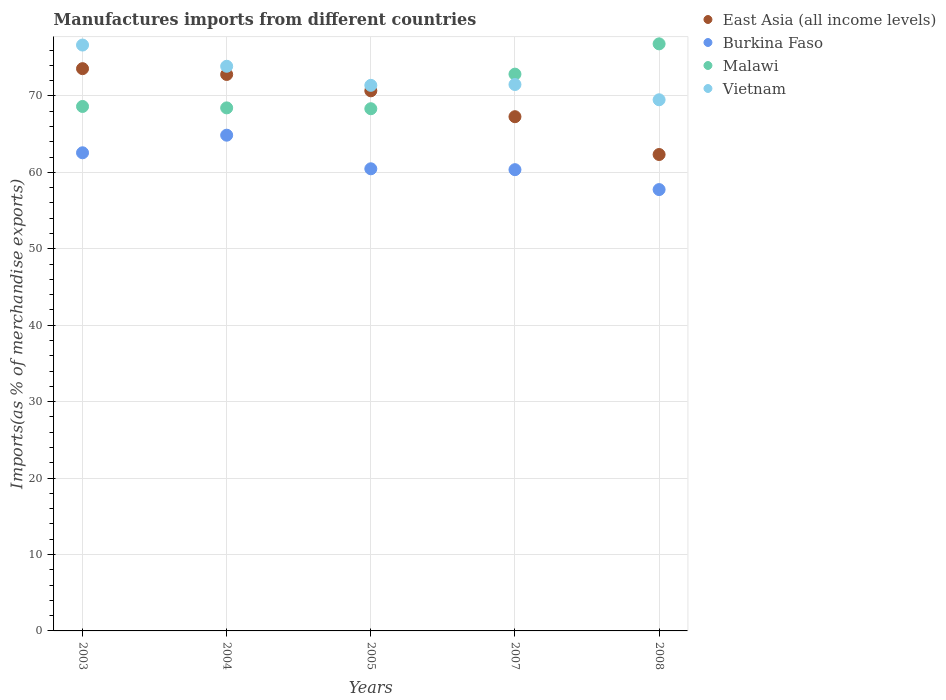How many different coloured dotlines are there?
Provide a succinct answer. 4. Is the number of dotlines equal to the number of legend labels?
Ensure brevity in your answer.  Yes. What is the percentage of imports to different countries in Malawi in 2007?
Ensure brevity in your answer.  72.86. Across all years, what is the maximum percentage of imports to different countries in Vietnam?
Your answer should be compact. 76.67. Across all years, what is the minimum percentage of imports to different countries in Vietnam?
Provide a short and direct response. 69.51. In which year was the percentage of imports to different countries in Malawi maximum?
Keep it short and to the point. 2008. In which year was the percentage of imports to different countries in East Asia (all income levels) minimum?
Your answer should be compact. 2008. What is the total percentage of imports to different countries in Vietnam in the graph?
Ensure brevity in your answer.  362.96. What is the difference between the percentage of imports to different countries in Vietnam in 2003 and that in 2005?
Offer a terse response. 5.27. What is the difference between the percentage of imports to different countries in East Asia (all income levels) in 2004 and the percentage of imports to different countries in Malawi in 2003?
Keep it short and to the point. 4.19. What is the average percentage of imports to different countries in Burkina Faso per year?
Your answer should be compact. 61.21. In the year 2007, what is the difference between the percentage of imports to different countries in Vietnam and percentage of imports to different countries in East Asia (all income levels)?
Your response must be concise. 4.21. In how many years, is the percentage of imports to different countries in Burkina Faso greater than 8 %?
Offer a terse response. 5. What is the ratio of the percentage of imports to different countries in Vietnam in 2005 to that in 2008?
Ensure brevity in your answer.  1.03. What is the difference between the highest and the second highest percentage of imports to different countries in Burkina Faso?
Provide a short and direct response. 2.3. What is the difference between the highest and the lowest percentage of imports to different countries in East Asia (all income levels)?
Give a very brief answer. 11.23. Is it the case that in every year, the sum of the percentage of imports to different countries in Vietnam and percentage of imports to different countries in East Asia (all income levels)  is greater than the percentage of imports to different countries in Burkina Faso?
Your answer should be compact. Yes. Does the percentage of imports to different countries in Vietnam monotonically increase over the years?
Your response must be concise. No. Is the percentage of imports to different countries in Burkina Faso strictly greater than the percentage of imports to different countries in East Asia (all income levels) over the years?
Your response must be concise. No. How many dotlines are there?
Give a very brief answer. 4. How many years are there in the graph?
Provide a short and direct response. 5. Does the graph contain grids?
Offer a terse response. Yes. Where does the legend appear in the graph?
Your answer should be compact. Top right. What is the title of the graph?
Provide a succinct answer. Manufactures imports from different countries. Does "Sudan" appear as one of the legend labels in the graph?
Offer a very short reply. No. What is the label or title of the X-axis?
Make the answer very short. Years. What is the label or title of the Y-axis?
Give a very brief answer. Imports(as % of merchandise exports). What is the Imports(as % of merchandise exports) of East Asia (all income levels) in 2003?
Your answer should be very brief. 73.58. What is the Imports(as % of merchandise exports) of Burkina Faso in 2003?
Offer a terse response. 62.57. What is the Imports(as % of merchandise exports) of Malawi in 2003?
Offer a terse response. 68.63. What is the Imports(as % of merchandise exports) of Vietnam in 2003?
Provide a succinct answer. 76.67. What is the Imports(as % of merchandise exports) of East Asia (all income levels) in 2004?
Provide a short and direct response. 72.82. What is the Imports(as % of merchandise exports) of Burkina Faso in 2004?
Offer a terse response. 64.87. What is the Imports(as % of merchandise exports) of Malawi in 2004?
Provide a succinct answer. 68.44. What is the Imports(as % of merchandise exports) in Vietnam in 2004?
Ensure brevity in your answer.  73.89. What is the Imports(as % of merchandise exports) in East Asia (all income levels) in 2005?
Your answer should be compact. 70.68. What is the Imports(as % of merchandise exports) in Burkina Faso in 2005?
Give a very brief answer. 60.47. What is the Imports(as % of merchandise exports) of Malawi in 2005?
Your response must be concise. 68.33. What is the Imports(as % of merchandise exports) in Vietnam in 2005?
Give a very brief answer. 71.39. What is the Imports(as % of merchandise exports) in East Asia (all income levels) in 2007?
Provide a succinct answer. 67.29. What is the Imports(as % of merchandise exports) in Burkina Faso in 2007?
Offer a terse response. 60.36. What is the Imports(as % of merchandise exports) of Malawi in 2007?
Keep it short and to the point. 72.86. What is the Imports(as % of merchandise exports) in Vietnam in 2007?
Keep it short and to the point. 71.5. What is the Imports(as % of merchandise exports) of East Asia (all income levels) in 2008?
Offer a very short reply. 62.34. What is the Imports(as % of merchandise exports) in Burkina Faso in 2008?
Your answer should be compact. 57.75. What is the Imports(as % of merchandise exports) in Malawi in 2008?
Make the answer very short. 76.82. What is the Imports(as % of merchandise exports) in Vietnam in 2008?
Your response must be concise. 69.51. Across all years, what is the maximum Imports(as % of merchandise exports) in East Asia (all income levels)?
Keep it short and to the point. 73.58. Across all years, what is the maximum Imports(as % of merchandise exports) of Burkina Faso?
Provide a short and direct response. 64.87. Across all years, what is the maximum Imports(as % of merchandise exports) in Malawi?
Make the answer very short. 76.82. Across all years, what is the maximum Imports(as % of merchandise exports) in Vietnam?
Your response must be concise. 76.67. Across all years, what is the minimum Imports(as % of merchandise exports) of East Asia (all income levels)?
Your answer should be very brief. 62.34. Across all years, what is the minimum Imports(as % of merchandise exports) in Burkina Faso?
Provide a short and direct response. 57.75. Across all years, what is the minimum Imports(as % of merchandise exports) in Malawi?
Provide a succinct answer. 68.33. Across all years, what is the minimum Imports(as % of merchandise exports) in Vietnam?
Provide a succinct answer. 69.51. What is the total Imports(as % of merchandise exports) of East Asia (all income levels) in the graph?
Offer a terse response. 346.71. What is the total Imports(as % of merchandise exports) in Burkina Faso in the graph?
Offer a very short reply. 306.03. What is the total Imports(as % of merchandise exports) in Malawi in the graph?
Keep it short and to the point. 355.09. What is the total Imports(as % of merchandise exports) in Vietnam in the graph?
Offer a terse response. 362.96. What is the difference between the Imports(as % of merchandise exports) in East Asia (all income levels) in 2003 and that in 2004?
Give a very brief answer. 0.76. What is the difference between the Imports(as % of merchandise exports) of Burkina Faso in 2003 and that in 2004?
Your answer should be very brief. -2.3. What is the difference between the Imports(as % of merchandise exports) in Malawi in 2003 and that in 2004?
Keep it short and to the point. 0.19. What is the difference between the Imports(as % of merchandise exports) of Vietnam in 2003 and that in 2004?
Ensure brevity in your answer.  2.78. What is the difference between the Imports(as % of merchandise exports) of East Asia (all income levels) in 2003 and that in 2005?
Give a very brief answer. 2.9. What is the difference between the Imports(as % of merchandise exports) of Burkina Faso in 2003 and that in 2005?
Your answer should be compact. 2.09. What is the difference between the Imports(as % of merchandise exports) of Malawi in 2003 and that in 2005?
Offer a terse response. 0.3. What is the difference between the Imports(as % of merchandise exports) of Vietnam in 2003 and that in 2005?
Keep it short and to the point. 5.27. What is the difference between the Imports(as % of merchandise exports) of East Asia (all income levels) in 2003 and that in 2007?
Ensure brevity in your answer.  6.29. What is the difference between the Imports(as % of merchandise exports) in Burkina Faso in 2003 and that in 2007?
Keep it short and to the point. 2.21. What is the difference between the Imports(as % of merchandise exports) in Malawi in 2003 and that in 2007?
Your answer should be compact. -4.23. What is the difference between the Imports(as % of merchandise exports) of Vietnam in 2003 and that in 2007?
Provide a short and direct response. 5.16. What is the difference between the Imports(as % of merchandise exports) of East Asia (all income levels) in 2003 and that in 2008?
Your answer should be very brief. 11.23. What is the difference between the Imports(as % of merchandise exports) of Burkina Faso in 2003 and that in 2008?
Keep it short and to the point. 4.81. What is the difference between the Imports(as % of merchandise exports) of Malawi in 2003 and that in 2008?
Your response must be concise. -8.19. What is the difference between the Imports(as % of merchandise exports) in Vietnam in 2003 and that in 2008?
Provide a short and direct response. 7.16. What is the difference between the Imports(as % of merchandise exports) of East Asia (all income levels) in 2004 and that in 2005?
Your response must be concise. 2.14. What is the difference between the Imports(as % of merchandise exports) in Burkina Faso in 2004 and that in 2005?
Your response must be concise. 4.4. What is the difference between the Imports(as % of merchandise exports) in Malawi in 2004 and that in 2005?
Your answer should be compact. 0.11. What is the difference between the Imports(as % of merchandise exports) in Vietnam in 2004 and that in 2005?
Ensure brevity in your answer.  2.5. What is the difference between the Imports(as % of merchandise exports) of East Asia (all income levels) in 2004 and that in 2007?
Keep it short and to the point. 5.53. What is the difference between the Imports(as % of merchandise exports) of Burkina Faso in 2004 and that in 2007?
Ensure brevity in your answer.  4.51. What is the difference between the Imports(as % of merchandise exports) in Malawi in 2004 and that in 2007?
Keep it short and to the point. -4.42. What is the difference between the Imports(as % of merchandise exports) in Vietnam in 2004 and that in 2007?
Your answer should be compact. 2.39. What is the difference between the Imports(as % of merchandise exports) of East Asia (all income levels) in 2004 and that in 2008?
Your answer should be very brief. 10.47. What is the difference between the Imports(as % of merchandise exports) in Burkina Faso in 2004 and that in 2008?
Offer a terse response. 7.12. What is the difference between the Imports(as % of merchandise exports) in Malawi in 2004 and that in 2008?
Your answer should be compact. -8.38. What is the difference between the Imports(as % of merchandise exports) of Vietnam in 2004 and that in 2008?
Keep it short and to the point. 4.39. What is the difference between the Imports(as % of merchandise exports) of East Asia (all income levels) in 2005 and that in 2007?
Your response must be concise. 3.39. What is the difference between the Imports(as % of merchandise exports) in Burkina Faso in 2005 and that in 2007?
Your answer should be very brief. 0.12. What is the difference between the Imports(as % of merchandise exports) in Malawi in 2005 and that in 2007?
Give a very brief answer. -4.53. What is the difference between the Imports(as % of merchandise exports) in Vietnam in 2005 and that in 2007?
Provide a short and direct response. -0.11. What is the difference between the Imports(as % of merchandise exports) of East Asia (all income levels) in 2005 and that in 2008?
Provide a succinct answer. 8.33. What is the difference between the Imports(as % of merchandise exports) in Burkina Faso in 2005 and that in 2008?
Your answer should be compact. 2.72. What is the difference between the Imports(as % of merchandise exports) in Malawi in 2005 and that in 2008?
Make the answer very short. -8.49. What is the difference between the Imports(as % of merchandise exports) of Vietnam in 2005 and that in 2008?
Keep it short and to the point. 1.89. What is the difference between the Imports(as % of merchandise exports) in East Asia (all income levels) in 2007 and that in 2008?
Keep it short and to the point. 4.95. What is the difference between the Imports(as % of merchandise exports) in Burkina Faso in 2007 and that in 2008?
Ensure brevity in your answer.  2.61. What is the difference between the Imports(as % of merchandise exports) in Malawi in 2007 and that in 2008?
Your response must be concise. -3.96. What is the difference between the Imports(as % of merchandise exports) in Vietnam in 2007 and that in 2008?
Provide a short and direct response. 2. What is the difference between the Imports(as % of merchandise exports) in East Asia (all income levels) in 2003 and the Imports(as % of merchandise exports) in Burkina Faso in 2004?
Offer a terse response. 8.71. What is the difference between the Imports(as % of merchandise exports) in East Asia (all income levels) in 2003 and the Imports(as % of merchandise exports) in Malawi in 2004?
Offer a very short reply. 5.13. What is the difference between the Imports(as % of merchandise exports) in East Asia (all income levels) in 2003 and the Imports(as % of merchandise exports) in Vietnam in 2004?
Ensure brevity in your answer.  -0.31. What is the difference between the Imports(as % of merchandise exports) in Burkina Faso in 2003 and the Imports(as % of merchandise exports) in Malawi in 2004?
Provide a short and direct response. -5.88. What is the difference between the Imports(as % of merchandise exports) in Burkina Faso in 2003 and the Imports(as % of merchandise exports) in Vietnam in 2004?
Your answer should be compact. -11.32. What is the difference between the Imports(as % of merchandise exports) in Malawi in 2003 and the Imports(as % of merchandise exports) in Vietnam in 2004?
Provide a short and direct response. -5.26. What is the difference between the Imports(as % of merchandise exports) in East Asia (all income levels) in 2003 and the Imports(as % of merchandise exports) in Burkina Faso in 2005?
Offer a terse response. 13.1. What is the difference between the Imports(as % of merchandise exports) in East Asia (all income levels) in 2003 and the Imports(as % of merchandise exports) in Malawi in 2005?
Provide a succinct answer. 5.24. What is the difference between the Imports(as % of merchandise exports) of East Asia (all income levels) in 2003 and the Imports(as % of merchandise exports) of Vietnam in 2005?
Provide a succinct answer. 2.18. What is the difference between the Imports(as % of merchandise exports) of Burkina Faso in 2003 and the Imports(as % of merchandise exports) of Malawi in 2005?
Make the answer very short. -5.77. What is the difference between the Imports(as % of merchandise exports) in Burkina Faso in 2003 and the Imports(as % of merchandise exports) in Vietnam in 2005?
Provide a succinct answer. -8.83. What is the difference between the Imports(as % of merchandise exports) of Malawi in 2003 and the Imports(as % of merchandise exports) of Vietnam in 2005?
Provide a succinct answer. -2.76. What is the difference between the Imports(as % of merchandise exports) of East Asia (all income levels) in 2003 and the Imports(as % of merchandise exports) of Burkina Faso in 2007?
Your answer should be very brief. 13.22. What is the difference between the Imports(as % of merchandise exports) in East Asia (all income levels) in 2003 and the Imports(as % of merchandise exports) in Malawi in 2007?
Offer a terse response. 0.72. What is the difference between the Imports(as % of merchandise exports) of East Asia (all income levels) in 2003 and the Imports(as % of merchandise exports) of Vietnam in 2007?
Ensure brevity in your answer.  2.08. What is the difference between the Imports(as % of merchandise exports) in Burkina Faso in 2003 and the Imports(as % of merchandise exports) in Malawi in 2007?
Give a very brief answer. -10.29. What is the difference between the Imports(as % of merchandise exports) in Burkina Faso in 2003 and the Imports(as % of merchandise exports) in Vietnam in 2007?
Offer a terse response. -8.93. What is the difference between the Imports(as % of merchandise exports) in Malawi in 2003 and the Imports(as % of merchandise exports) in Vietnam in 2007?
Offer a terse response. -2.87. What is the difference between the Imports(as % of merchandise exports) in East Asia (all income levels) in 2003 and the Imports(as % of merchandise exports) in Burkina Faso in 2008?
Keep it short and to the point. 15.82. What is the difference between the Imports(as % of merchandise exports) of East Asia (all income levels) in 2003 and the Imports(as % of merchandise exports) of Malawi in 2008?
Provide a succinct answer. -3.24. What is the difference between the Imports(as % of merchandise exports) in East Asia (all income levels) in 2003 and the Imports(as % of merchandise exports) in Vietnam in 2008?
Make the answer very short. 4.07. What is the difference between the Imports(as % of merchandise exports) of Burkina Faso in 2003 and the Imports(as % of merchandise exports) of Malawi in 2008?
Make the answer very short. -14.25. What is the difference between the Imports(as % of merchandise exports) of Burkina Faso in 2003 and the Imports(as % of merchandise exports) of Vietnam in 2008?
Offer a very short reply. -6.94. What is the difference between the Imports(as % of merchandise exports) in Malawi in 2003 and the Imports(as % of merchandise exports) in Vietnam in 2008?
Give a very brief answer. -0.88. What is the difference between the Imports(as % of merchandise exports) in East Asia (all income levels) in 2004 and the Imports(as % of merchandise exports) in Burkina Faso in 2005?
Keep it short and to the point. 12.34. What is the difference between the Imports(as % of merchandise exports) in East Asia (all income levels) in 2004 and the Imports(as % of merchandise exports) in Malawi in 2005?
Give a very brief answer. 4.48. What is the difference between the Imports(as % of merchandise exports) in East Asia (all income levels) in 2004 and the Imports(as % of merchandise exports) in Vietnam in 2005?
Your answer should be very brief. 1.42. What is the difference between the Imports(as % of merchandise exports) of Burkina Faso in 2004 and the Imports(as % of merchandise exports) of Malawi in 2005?
Offer a terse response. -3.46. What is the difference between the Imports(as % of merchandise exports) of Burkina Faso in 2004 and the Imports(as % of merchandise exports) of Vietnam in 2005?
Your answer should be very brief. -6.52. What is the difference between the Imports(as % of merchandise exports) in Malawi in 2004 and the Imports(as % of merchandise exports) in Vietnam in 2005?
Provide a short and direct response. -2.95. What is the difference between the Imports(as % of merchandise exports) of East Asia (all income levels) in 2004 and the Imports(as % of merchandise exports) of Burkina Faso in 2007?
Keep it short and to the point. 12.46. What is the difference between the Imports(as % of merchandise exports) in East Asia (all income levels) in 2004 and the Imports(as % of merchandise exports) in Malawi in 2007?
Provide a succinct answer. -0.04. What is the difference between the Imports(as % of merchandise exports) in East Asia (all income levels) in 2004 and the Imports(as % of merchandise exports) in Vietnam in 2007?
Your answer should be very brief. 1.32. What is the difference between the Imports(as % of merchandise exports) of Burkina Faso in 2004 and the Imports(as % of merchandise exports) of Malawi in 2007?
Offer a terse response. -7.99. What is the difference between the Imports(as % of merchandise exports) of Burkina Faso in 2004 and the Imports(as % of merchandise exports) of Vietnam in 2007?
Give a very brief answer. -6.63. What is the difference between the Imports(as % of merchandise exports) of Malawi in 2004 and the Imports(as % of merchandise exports) of Vietnam in 2007?
Provide a short and direct response. -3.06. What is the difference between the Imports(as % of merchandise exports) in East Asia (all income levels) in 2004 and the Imports(as % of merchandise exports) in Burkina Faso in 2008?
Your answer should be very brief. 15.06. What is the difference between the Imports(as % of merchandise exports) in East Asia (all income levels) in 2004 and the Imports(as % of merchandise exports) in Malawi in 2008?
Your answer should be compact. -4. What is the difference between the Imports(as % of merchandise exports) in East Asia (all income levels) in 2004 and the Imports(as % of merchandise exports) in Vietnam in 2008?
Provide a succinct answer. 3.31. What is the difference between the Imports(as % of merchandise exports) in Burkina Faso in 2004 and the Imports(as % of merchandise exports) in Malawi in 2008?
Provide a short and direct response. -11.95. What is the difference between the Imports(as % of merchandise exports) in Burkina Faso in 2004 and the Imports(as % of merchandise exports) in Vietnam in 2008?
Provide a short and direct response. -4.63. What is the difference between the Imports(as % of merchandise exports) of Malawi in 2004 and the Imports(as % of merchandise exports) of Vietnam in 2008?
Your answer should be very brief. -1.06. What is the difference between the Imports(as % of merchandise exports) of East Asia (all income levels) in 2005 and the Imports(as % of merchandise exports) of Burkina Faso in 2007?
Your answer should be very brief. 10.32. What is the difference between the Imports(as % of merchandise exports) in East Asia (all income levels) in 2005 and the Imports(as % of merchandise exports) in Malawi in 2007?
Keep it short and to the point. -2.18. What is the difference between the Imports(as % of merchandise exports) in East Asia (all income levels) in 2005 and the Imports(as % of merchandise exports) in Vietnam in 2007?
Provide a short and direct response. -0.82. What is the difference between the Imports(as % of merchandise exports) of Burkina Faso in 2005 and the Imports(as % of merchandise exports) of Malawi in 2007?
Your answer should be very brief. -12.39. What is the difference between the Imports(as % of merchandise exports) of Burkina Faso in 2005 and the Imports(as % of merchandise exports) of Vietnam in 2007?
Provide a short and direct response. -11.03. What is the difference between the Imports(as % of merchandise exports) of Malawi in 2005 and the Imports(as % of merchandise exports) of Vietnam in 2007?
Your response must be concise. -3.17. What is the difference between the Imports(as % of merchandise exports) in East Asia (all income levels) in 2005 and the Imports(as % of merchandise exports) in Burkina Faso in 2008?
Your response must be concise. 12.92. What is the difference between the Imports(as % of merchandise exports) of East Asia (all income levels) in 2005 and the Imports(as % of merchandise exports) of Malawi in 2008?
Provide a succinct answer. -6.14. What is the difference between the Imports(as % of merchandise exports) in East Asia (all income levels) in 2005 and the Imports(as % of merchandise exports) in Vietnam in 2008?
Keep it short and to the point. 1.17. What is the difference between the Imports(as % of merchandise exports) of Burkina Faso in 2005 and the Imports(as % of merchandise exports) of Malawi in 2008?
Offer a terse response. -16.35. What is the difference between the Imports(as % of merchandise exports) in Burkina Faso in 2005 and the Imports(as % of merchandise exports) in Vietnam in 2008?
Offer a very short reply. -9.03. What is the difference between the Imports(as % of merchandise exports) of Malawi in 2005 and the Imports(as % of merchandise exports) of Vietnam in 2008?
Make the answer very short. -1.17. What is the difference between the Imports(as % of merchandise exports) in East Asia (all income levels) in 2007 and the Imports(as % of merchandise exports) in Burkina Faso in 2008?
Offer a very short reply. 9.54. What is the difference between the Imports(as % of merchandise exports) in East Asia (all income levels) in 2007 and the Imports(as % of merchandise exports) in Malawi in 2008?
Ensure brevity in your answer.  -9.53. What is the difference between the Imports(as % of merchandise exports) in East Asia (all income levels) in 2007 and the Imports(as % of merchandise exports) in Vietnam in 2008?
Your answer should be compact. -2.21. What is the difference between the Imports(as % of merchandise exports) in Burkina Faso in 2007 and the Imports(as % of merchandise exports) in Malawi in 2008?
Your answer should be very brief. -16.46. What is the difference between the Imports(as % of merchandise exports) in Burkina Faso in 2007 and the Imports(as % of merchandise exports) in Vietnam in 2008?
Give a very brief answer. -9.15. What is the difference between the Imports(as % of merchandise exports) of Malawi in 2007 and the Imports(as % of merchandise exports) of Vietnam in 2008?
Offer a very short reply. 3.35. What is the average Imports(as % of merchandise exports) in East Asia (all income levels) per year?
Ensure brevity in your answer.  69.34. What is the average Imports(as % of merchandise exports) in Burkina Faso per year?
Your answer should be compact. 61.21. What is the average Imports(as % of merchandise exports) of Malawi per year?
Provide a short and direct response. 71.02. What is the average Imports(as % of merchandise exports) of Vietnam per year?
Provide a succinct answer. 72.59. In the year 2003, what is the difference between the Imports(as % of merchandise exports) of East Asia (all income levels) and Imports(as % of merchandise exports) of Burkina Faso?
Your answer should be very brief. 11.01. In the year 2003, what is the difference between the Imports(as % of merchandise exports) in East Asia (all income levels) and Imports(as % of merchandise exports) in Malawi?
Your answer should be compact. 4.95. In the year 2003, what is the difference between the Imports(as % of merchandise exports) of East Asia (all income levels) and Imports(as % of merchandise exports) of Vietnam?
Keep it short and to the point. -3.09. In the year 2003, what is the difference between the Imports(as % of merchandise exports) in Burkina Faso and Imports(as % of merchandise exports) in Malawi?
Your answer should be compact. -6.06. In the year 2003, what is the difference between the Imports(as % of merchandise exports) of Burkina Faso and Imports(as % of merchandise exports) of Vietnam?
Offer a very short reply. -14.1. In the year 2003, what is the difference between the Imports(as % of merchandise exports) in Malawi and Imports(as % of merchandise exports) in Vietnam?
Your answer should be very brief. -8.04. In the year 2004, what is the difference between the Imports(as % of merchandise exports) in East Asia (all income levels) and Imports(as % of merchandise exports) in Burkina Faso?
Offer a very short reply. 7.95. In the year 2004, what is the difference between the Imports(as % of merchandise exports) of East Asia (all income levels) and Imports(as % of merchandise exports) of Malawi?
Provide a succinct answer. 4.37. In the year 2004, what is the difference between the Imports(as % of merchandise exports) in East Asia (all income levels) and Imports(as % of merchandise exports) in Vietnam?
Keep it short and to the point. -1.07. In the year 2004, what is the difference between the Imports(as % of merchandise exports) in Burkina Faso and Imports(as % of merchandise exports) in Malawi?
Give a very brief answer. -3.57. In the year 2004, what is the difference between the Imports(as % of merchandise exports) in Burkina Faso and Imports(as % of merchandise exports) in Vietnam?
Your response must be concise. -9.02. In the year 2004, what is the difference between the Imports(as % of merchandise exports) in Malawi and Imports(as % of merchandise exports) in Vietnam?
Keep it short and to the point. -5.45. In the year 2005, what is the difference between the Imports(as % of merchandise exports) in East Asia (all income levels) and Imports(as % of merchandise exports) in Burkina Faso?
Ensure brevity in your answer.  10.2. In the year 2005, what is the difference between the Imports(as % of merchandise exports) in East Asia (all income levels) and Imports(as % of merchandise exports) in Malawi?
Offer a terse response. 2.34. In the year 2005, what is the difference between the Imports(as % of merchandise exports) in East Asia (all income levels) and Imports(as % of merchandise exports) in Vietnam?
Your answer should be very brief. -0.72. In the year 2005, what is the difference between the Imports(as % of merchandise exports) of Burkina Faso and Imports(as % of merchandise exports) of Malawi?
Offer a terse response. -7.86. In the year 2005, what is the difference between the Imports(as % of merchandise exports) of Burkina Faso and Imports(as % of merchandise exports) of Vietnam?
Keep it short and to the point. -10.92. In the year 2005, what is the difference between the Imports(as % of merchandise exports) in Malawi and Imports(as % of merchandise exports) in Vietnam?
Offer a very short reply. -3.06. In the year 2007, what is the difference between the Imports(as % of merchandise exports) of East Asia (all income levels) and Imports(as % of merchandise exports) of Burkina Faso?
Ensure brevity in your answer.  6.93. In the year 2007, what is the difference between the Imports(as % of merchandise exports) in East Asia (all income levels) and Imports(as % of merchandise exports) in Malawi?
Your answer should be very brief. -5.57. In the year 2007, what is the difference between the Imports(as % of merchandise exports) of East Asia (all income levels) and Imports(as % of merchandise exports) of Vietnam?
Offer a terse response. -4.21. In the year 2007, what is the difference between the Imports(as % of merchandise exports) in Burkina Faso and Imports(as % of merchandise exports) in Malawi?
Your answer should be very brief. -12.5. In the year 2007, what is the difference between the Imports(as % of merchandise exports) in Burkina Faso and Imports(as % of merchandise exports) in Vietnam?
Give a very brief answer. -11.14. In the year 2007, what is the difference between the Imports(as % of merchandise exports) of Malawi and Imports(as % of merchandise exports) of Vietnam?
Ensure brevity in your answer.  1.36. In the year 2008, what is the difference between the Imports(as % of merchandise exports) in East Asia (all income levels) and Imports(as % of merchandise exports) in Burkina Faso?
Provide a succinct answer. 4.59. In the year 2008, what is the difference between the Imports(as % of merchandise exports) of East Asia (all income levels) and Imports(as % of merchandise exports) of Malawi?
Your answer should be compact. -14.48. In the year 2008, what is the difference between the Imports(as % of merchandise exports) in East Asia (all income levels) and Imports(as % of merchandise exports) in Vietnam?
Keep it short and to the point. -7.16. In the year 2008, what is the difference between the Imports(as % of merchandise exports) of Burkina Faso and Imports(as % of merchandise exports) of Malawi?
Your answer should be very brief. -19.07. In the year 2008, what is the difference between the Imports(as % of merchandise exports) in Burkina Faso and Imports(as % of merchandise exports) in Vietnam?
Provide a succinct answer. -11.75. In the year 2008, what is the difference between the Imports(as % of merchandise exports) in Malawi and Imports(as % of merchandise exports) in Vietnam?
Give a very brief answer. 7.32. What is the ratio of the Imports(as % of merchandise exports) of East Asia (all income levels) in 2003 to that in 2004?
Your answer should be compact. 1.01. What is the ratio of the Imports(as % of merchandise exports) in Burkina Faso in 2003 to that in 2004?
Your answer should be compact. 0.96. What is the ratio of the Imports(as % of merchandise exports) in Malawi in 2003 to that in 2004?
Your answer should be compact. 1. What is the ratio of the Imports(as % of merchandise exports) of Vietnam in 2003 to that in 2004?
Offer a very short reply. 1.04. What is the ratio of the Imports(as % of merchandise exports) of East Asia (all income levels) in 2003 to that in 2005?
Ensure brevity in your answer.  1.04. What is the ratio of the Imports(as % of merchandise exports) in Burkina Faso in 2003 to that in 2005?
Your answer should be very brief. 1.03. What is the ratio of the Imports(as % of merchandise exports) in Malawi in 2003 to that in 2005?
Provide a short and direct response. 1. What is the ratio of the Imports(as % of merchandise exports) in Vietnam in 2003 to that in 2005?
Provide a succinct answer. 1.07. What is the ratio of the Imports(as % of merchandise exports) in East Asia (all income levels) in 2003 to that in 2007?
Offer a terse response. 1.09. What is the ratio of the Imports(as % of merchandise exports) in Burkina Faso in 2003 to that in 2007?
Your response must be concise. 1.04. What is the ratio of the Imports(as % of merchandise exports) in Malawi in 2003 to that in 2007?
Make the answer very short. 0.94. What is the ratio of the Imports(as % of merchandise exports) in Vietnam in 2003 to that in 2007?
Offer a very short reply. 1.07. What is the ratio of the Imports(as % of merchandise exports) of East Asia (all income levels) in 2003 to that in 2008?
Make the answer very short. 1.18. What is the ratio of the Imports(as % of merchandise exports) in Burkina Faso in 2003 to that in 2008?
Offer a terse response. 1.08. What is the ratio of the Imports(as % of merchandise exports) of Malawi in 2003 to that in 2008?
Offer a very short reply. 0.89. What is the ratio of the Imports(as % of merchandise exports) in Vietnam in 2003 to that in 2008?
Keep it short and to the point. 1.1. What is the ratio of the Imports(as % of merchandise exports) in East Asia (all income levels) in 2004 to that in 2005?
Give a very brief answer. 1.03. What is the ratio of the Imports(as % of merchandise exports) in Burkina Faso in 2004 to that in 2005?
Your answer should be compact. 1.07. What is the ratio of the Imports(as % of merchandise exports) of Malawi in 2004 to that in 2005?
Make the answer very short. 1. What is the ratio of the Imports(as % of merchandise exports) of Vietnam in 2004 to that in 2005?
Give a very brief answer. 1.03. What is the ratio of the Imports(as % of merchandise exports) in East Asia (all income levels) in 2004 to that in 2007?
Ensure brevity in your answer.  1.08. What is the ratio of the Imports(as % of merchandise exports) of Burkina Faso in 2004 to that in 2007?
Provide a succinct answer. 1.07. What is the ratio of the Imports(as % of merchandise exports) in Malawi in 2004 to that in 2007?
Ensure brevity in your answer.  0.94. What is the ratio of the Imports(as % of merchandise exports) in Vietnam in 2004 to that in 2007?
Provide a succinct answer. 1.03. What is the ratio of the Imports(as % of merchandise exports) of East Asia (all income levels) in 2004 to that in 2008?
Keep it short and to the point. 1.17. What is the ratio of the Imports(as % of merchandise exports) in Burkina Faso in 2004 to that in 2008?
Ensure brevity in your answer.  1.12. What is the ratio of the Imports(as % of merchandise exports) of Malawi in 2004 to that in 2008?
Your response must be concise. 0.89. What is the ratio of the Imports(as % of merchandise exports) in Vietnam in 2004 to that in 2008?
Offer a very short reply. 1.06. What is the ratio of the Imports(as % of merchandise exports) of East Asia (all income levels) in 2005 to that in 2007?
Give a very brief answer. 1.05. What is the ratio of the Imports(as % of merchandise exports) of Malawi in 2005 to that in 2007?
Your answer should be compact. 0.94. What is the ratio of the Imports(as % of merchandise exports) of East Asia (all income levels) in 2005 to that in 2008?
Keep it short and to the point. 1.13. What is the ratio of the Imports(as % of merchandise exports) of Burkina Faso in 2005 to that in 2008?
Your response must be concise. 1.05. What is the ratio of the Imports(as % of merchandise exports) of Malawi in 2005 to that in 2008?
Your answer should be compact. 0.89. What is the ratio of the Imports(as % of merchandise exports) of Vietnam in 2005 to that in 2008?
Ensure brevity in your answer.  1.03. What is the ratio of the Imports(as % of merchandise exports) in East Asia (all income levels) in 2007 to that in 2008?
Your answer should be compact. 1.08. What is the ratio of the Imports(as % of merchandise exports) of Burkina Faso in 2007 to that in 2008?
Your response must be concise. 1.05. What is the ratio of the Imports(as % of merchandise exports) in Malawi in 2007 to that in 2008?
Your answer should be compact. 0.95. What is the ratio of the Imports(as % of merchandise exports) of Vietnam in 2007 to that in 2008?
Your response must be concise. 1.03. What is the difference between the highest and the second highest Imports(as % of merchandise exports) in East Asia (all income levels)?
Offer a terse response. 0.76. What is the difference between the highest and the second highest Imports(as % of merchandise exports) in Burkina Faso?
Your response must be concise. 2.3. What is the difference between the highest and the second highest Imports(as % of merchandise exports) in Malawi?
Offer a terse response. 3.96. What is the difference between the highest and the second highest Imports(as % of merchandise exports) of Vietnam?
Make the answer very short. 2.78. What is the difference between the highest and the lowest Imports(as % of merchandise exports) of East Asia (all income levels)?
Offer a terse response. 11.23. What is the difference between the highest and the lowest Imports(as % of merchandise exports) in Burkina Faso?
Your answer should be very brief. 7.12. What is the difference between the highest and the lowest Imports(as % of merchandise exports) in Malawi?
Ensure brevity in your answer.  8.49. What is the difference between the highest and the lowest Imports(as % of merchandise exports) in Vietnam?
Keep it short and to the point. 7.16. 